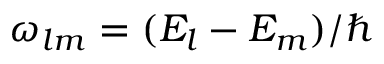Convert formula to latex. <formula><loc_0><loc_0><loc_500><loc_500>\omega _ { l m } = ( E _ { l } - E _ { m } ) / \hbar</formula> 